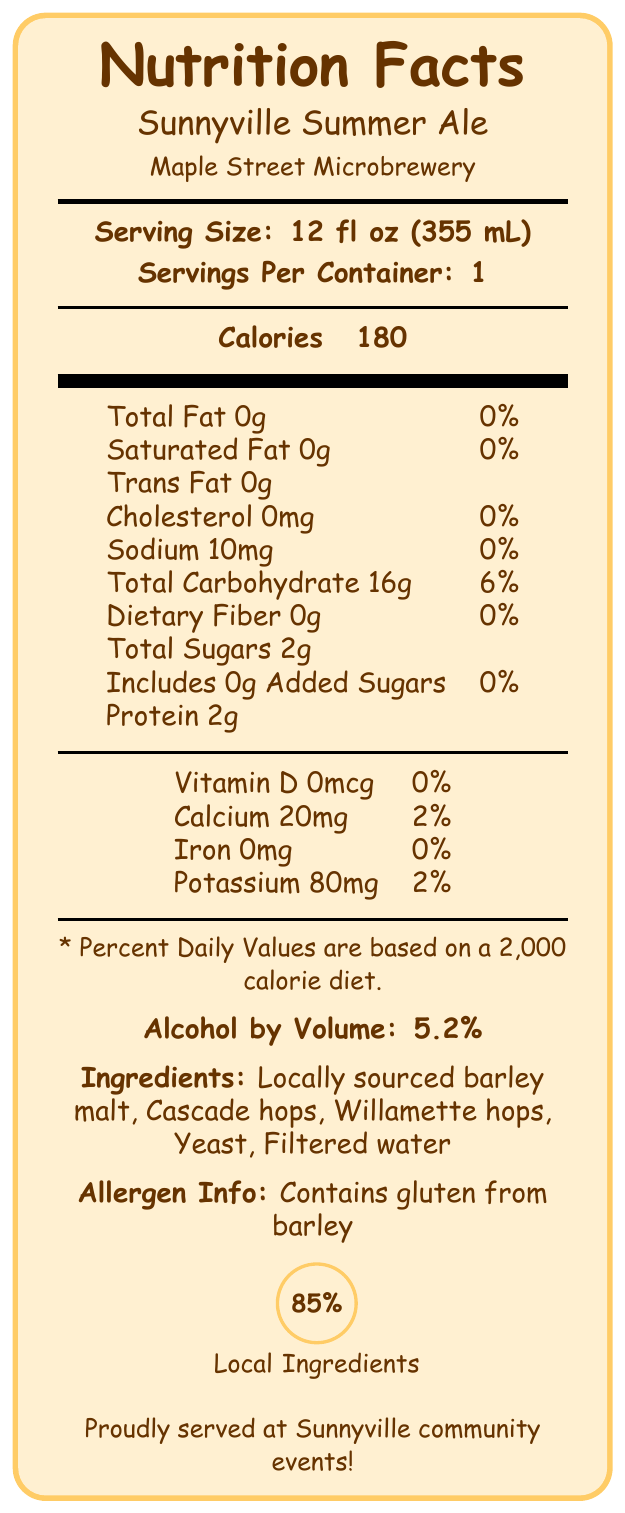what is the serving size of Sunnyville Summer Ale? The label clearly indicates that the serving size is 12 fl oz (355 mL).
Answer: 12 fl oz (355 mL) how many calories are there in one serving of Sunnyville Summer Ale? The label states that there are 180 calories per serving.
Answer: 180 how much sodium is in the beer? The label shows that there is 10mg of sodium in Sunnyville Summer Ale.
Answer: 10mg what is the alcohol by volume (ABV) percentage? The label specifies that the alcohol by volume (ABV) is 5.2%.
Answer: 5.2% is there any dietary fiber in Sunnyville Summer Ale? The label indicates that there is 0g of dietary fiber.
Answer: No what events is this beer served at in the community? A. Sunnyville Summer Festival B. Harvest Moon Celebration C. Main Street Food Truck Fridays D. All of the above The label lists all three community events: Sunnyville Summer Festival, Harvest Moon Celebration, and Main Street Food Truck Fridays.
Answer: D. All of the above which ingredient is not listed on the label? A. Cascade hops B. Willamette hops C. Sugar D. Yeast The ingredient list includes locally sourced barley malt, Cascade hops, Willamette hops, yeast, and filtered water, but not sugar.
Answer: C. Sugar does Sunnyville Summer Ale contain any gluten? The allergen info section of the label clearly states that it contains gluten from barley.
Answer: Yes list any sustainability efforts made by the Maple Street Microbrewery. The sustainability efforts section of the label details these practices.
Answer: Spent grain usage donated to local farmers for animal feed, implements closed-loop cooling system, uses recyclable cans and biodegradable six-pack holders summarize the main details provided on the label. The label provides information on the nutritional content, ingredients, allergen information, local community engagement, and sustainability efforts of Sunnyville Summer Ale.
Answer: Sunnyville Summer Ale from Maple Street Microbrewery has 180 calories per 12 fl oz serving. It's a light-bodied beer with 5.2% ABV, containing local ingredients. It includes 85% local ingredients, is served at various community events, and the brewery has significant sustainability efforts. what percentage of local ingredients is used in the beer? The label includes a diagram indicating that 85% of the ingredients are locally sourced.
Answer: 85% how many grams of protein are in a serving? The label states that there are 2g of protein in a serving.
Answer: 2g are there any added sugars in the beer? The label clearly mentions that there are 0g of added sugars.
Answer: No what is the mouthfeel of Sunnyville Summer Ale according to the tasting notes? The tasting notes section describes the mouthfeel as light-bodied with moderate carbonation.
Answer: Light-bodied with moderate carbonation how much calcium is in the beer? The label shows that there is 20mg of calcium per serving.
Answer: 20mg how much iron is in a serving of Sunnyville Summer Ale? The label states that there is 0mg of iron.
Answer: 0mg what is the annual production of Sunnyville Summer Ale? The label does not provide the specific annual production amount; thus, it's not possible to determine this information from the label alone.
Answer: Cannot be determined 